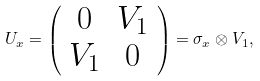Convert formula to latex. <formula><loc_0><loc_0><loc_500><loc_500>U _ { x } = \left ( \begin{array} { c c } 0 & V _ { 1 } \\ V _ { 1 } & 0 \end{array} \right ) = \sigma _ { x } \otimes V _ { 1 } ,</formula> 